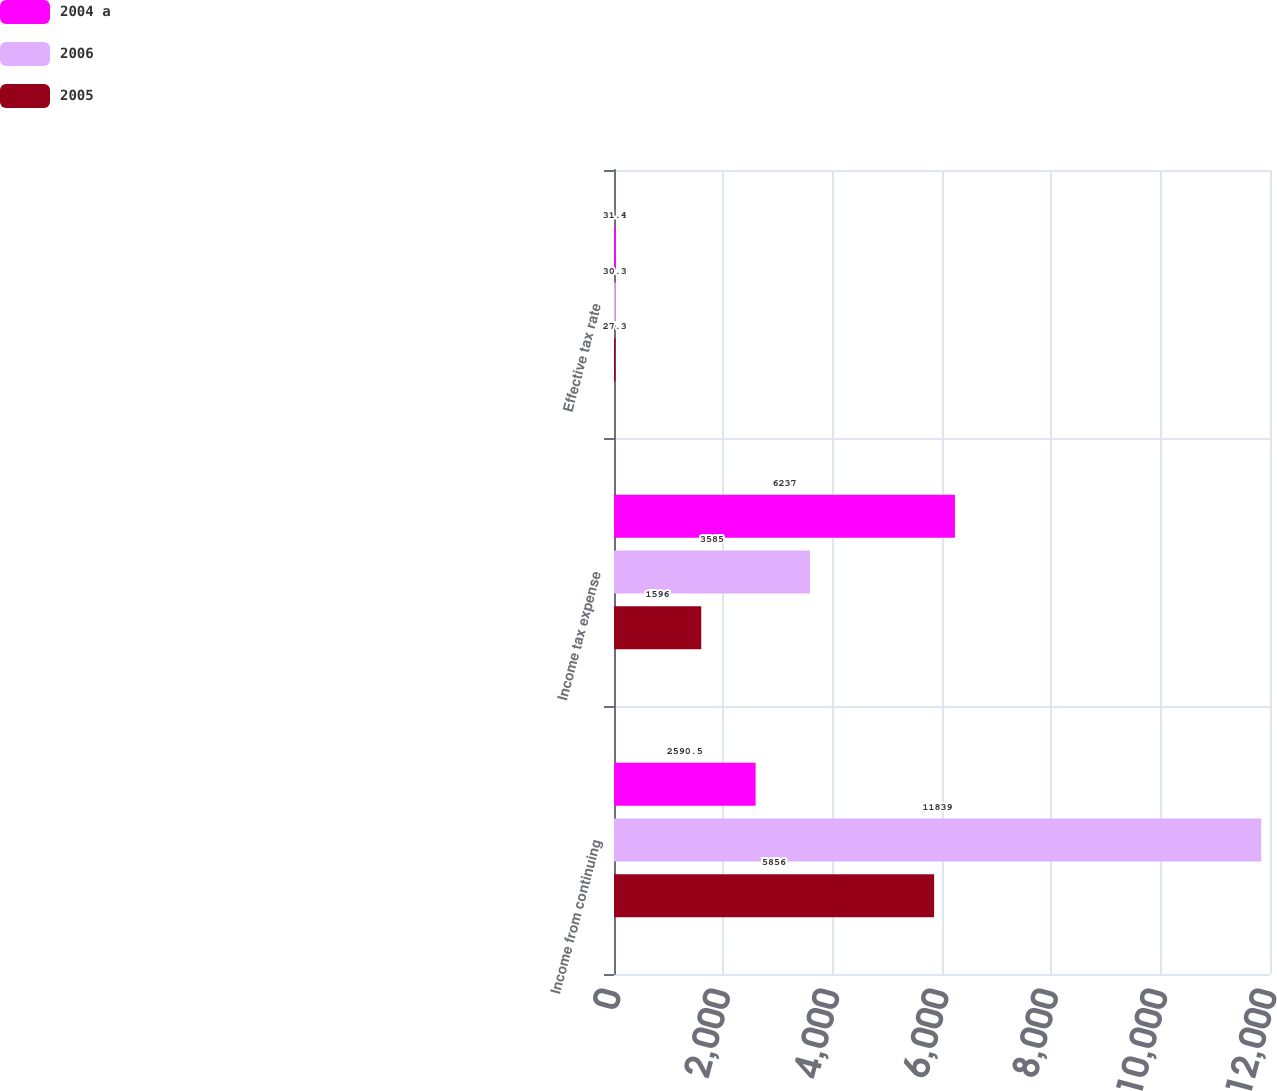Convert chart to OTSL. <chart><loc_0><loc_0><loc_500><loc_500><stacked_bar_chart><ecel><fcel>Income from continuing<fcel>Income tax expense<fcel>Effective tax rate<nl><fcel>2004 a<fcel>2590.5<fcel>6237<fcel>31.4<nl><fcel>2006<fcel>11839<fcel>3585<fcel>30.3<nl><fcel>2005<fcel>5856<fcel>1596<fcel>27.3<nl></chart> 